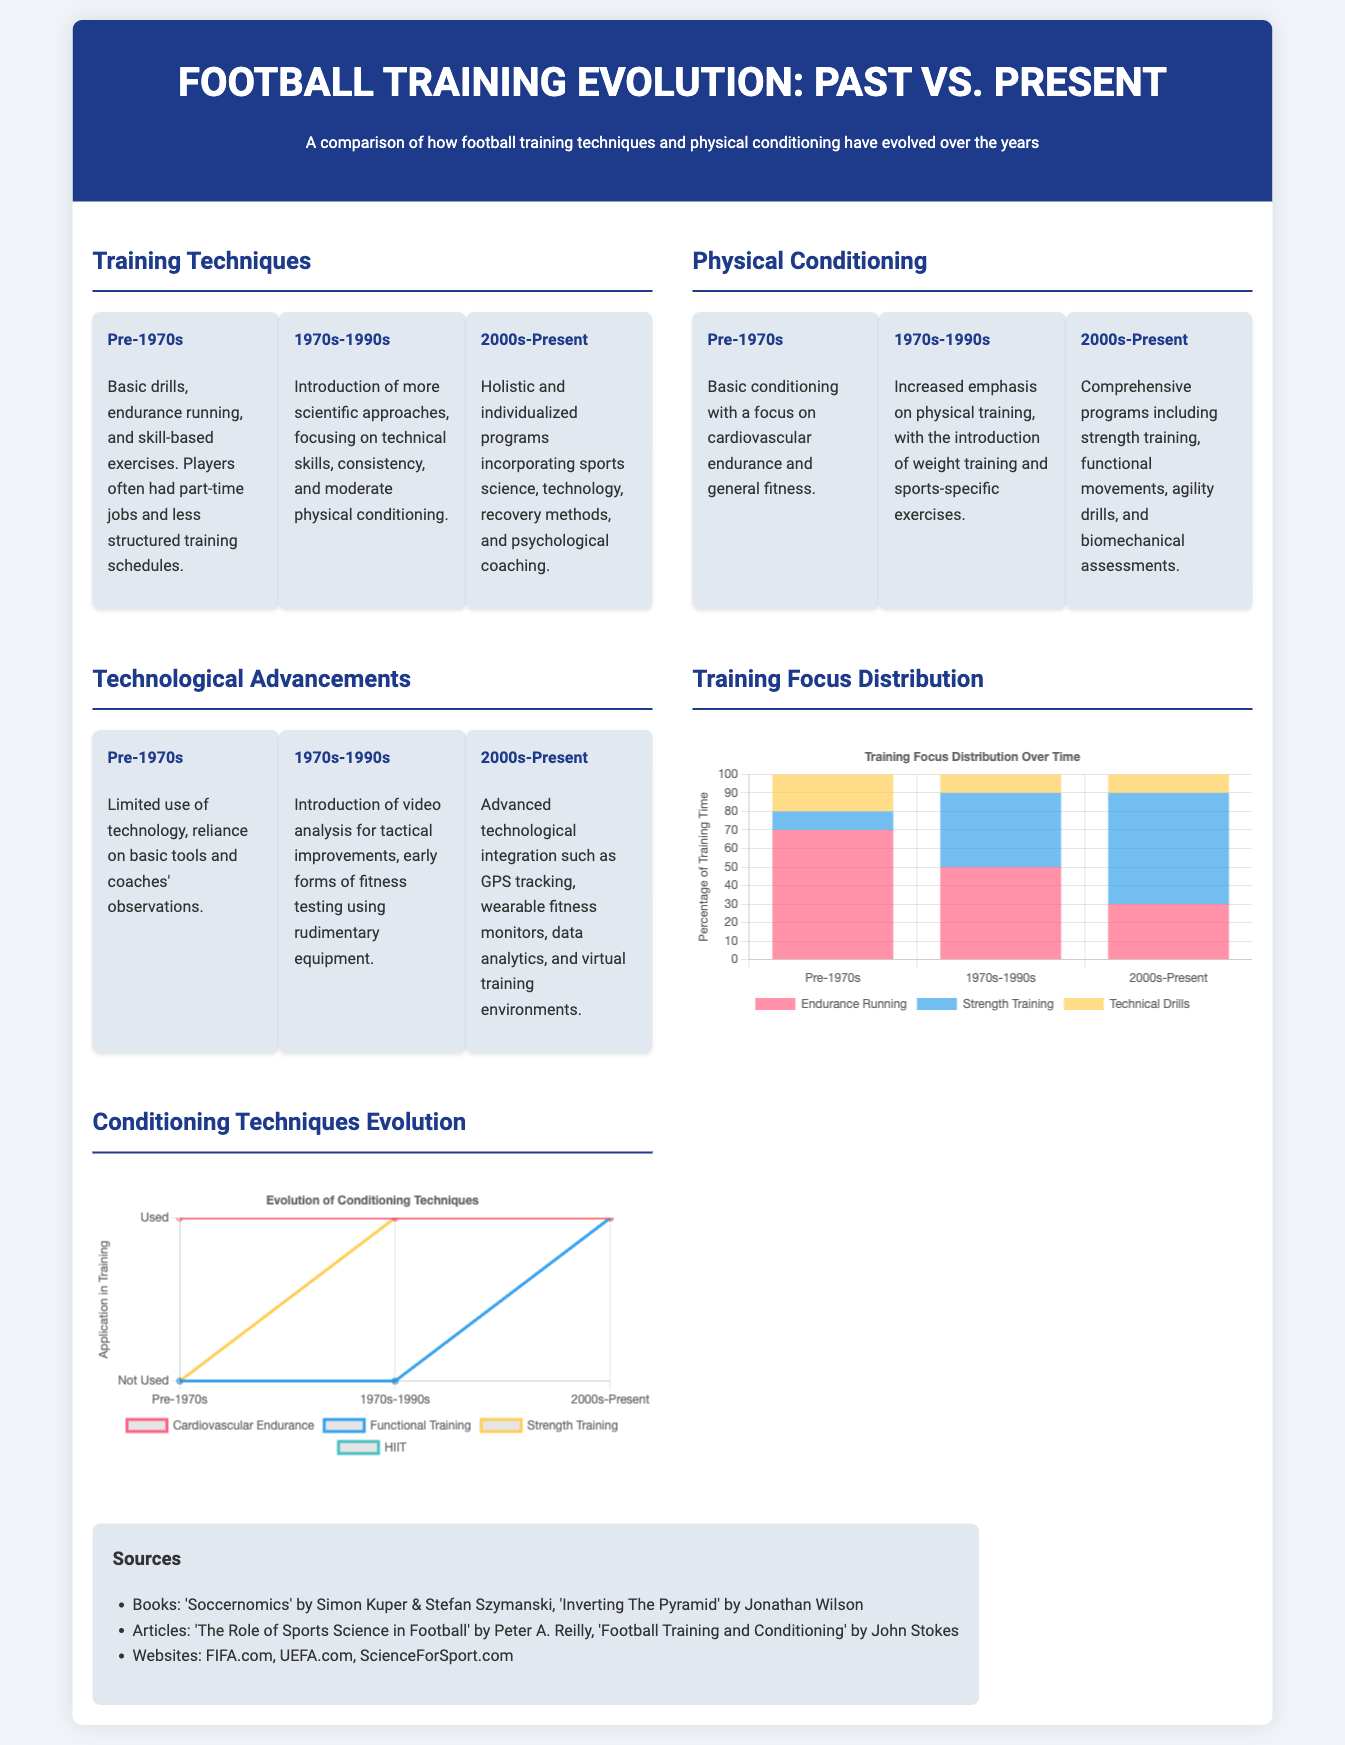What are the training techniques used before the 1970s? The document states that pre-1970s training techniques included basic drills, endurance running, and skill-based exercises.
Answer: Basic drills, endurance running, and skill-based exercises What type of conditioning was emphasized in the 1970s to 1990s? During this period, the document mentions increased emphasis on physical training with the introduction of weight training and sports-specific exercises.
Answer: Weight training and sports-specific exercises What is the focus of training in the 2000s to present? Current training focuses on holistic and individualized programs incorporating sports science, technology, recovery methods, and psychological coaching.
Answer: Holistic and individualized programs Which new fitness technology became apparent from the 2000s onwards? The document indicates advanced technological integration such as GPS tracking, wearable fitness monitors, and data analytics as key advancements in this era.
Answer: GPS tracking, wearable fitness monitors, and data analytics What was the percentage of endurance running in training time before the 1970s? According to the training chart, endurance running represented 70% of training time in the pre-1970s category.
Answer: 70% How has the use of functional training changed over time? The document displays that functional training was not used before the 2000s but is now an essential part of training programs.
Answer: Not Used to Used What is the main focus of the infographic? The main focus is to compare the evolution of football training techniques and physical conditioning over time.
Answer: Evolution of football training techniques and physical conditioning Which decade marks the transition to the use of video analysis for tactical improvements? The document states that video analysis started being introduced in the 1970s to 1990s for tactical improvements.
Answer: 1970s to 1990s 